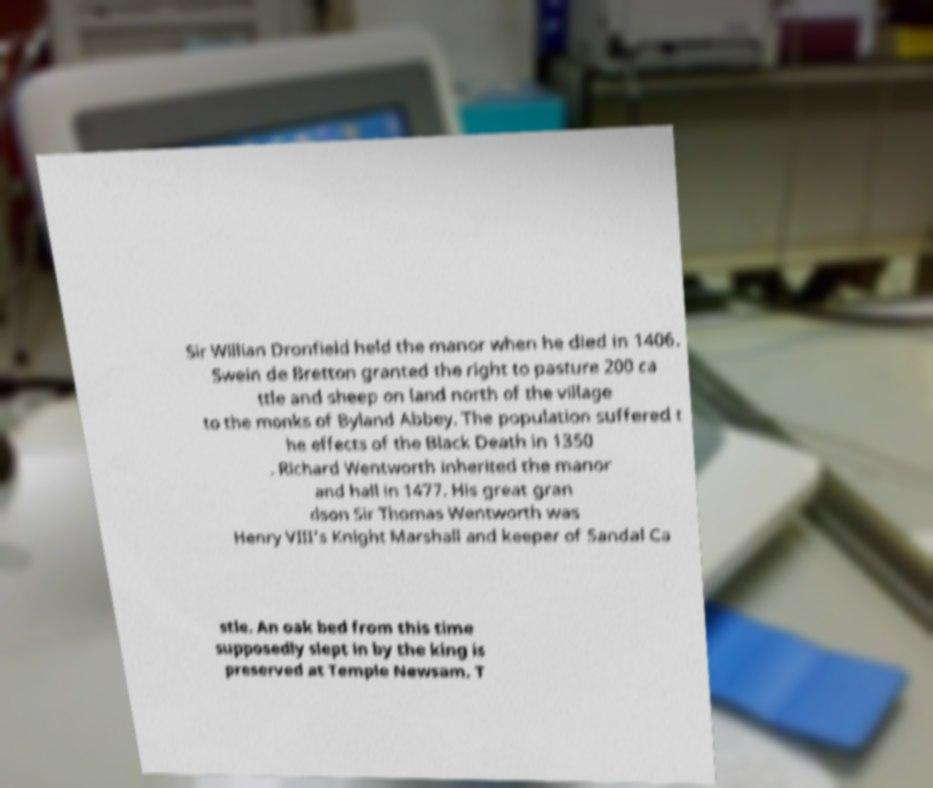For documentation purposes, I need the text within this image transcribed. Could you provide that? Sir Willian Dronfield held the manor when he died in 1406. Swein de Bretton granted the right to pasture 200 ca ttle and sheep on land north of the village to the monks of Byland Abbey. The population suffered t he effects of the Black Death in 1350 . Richard Wentworth inherited the manor and hall in 1477. His great gran dson Sir Thomas Wentworth was Henry VIII's Knight Marshall and keeper of Sandal Ca stle. An oak bed from this time supposedly slept in by the king is preserved at Temple Newsam. T 